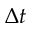<formula> <loc_0><loc_0><loc_500><loc_500>\Delta t</formula> 